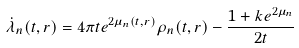Convert formula to latex. <formula><loc_0><loc_0><loc_500><loc_500>\dot { \lambda } _ { n } ( t , r ) = 4 \pi t e ^ { 2 \mu _ { n } ( t , r ) } \rho _ { n } ( t , r ) - \frac { 1 + k e ^ { 2 \mu _ { n } } } { 2 t }</formula> 